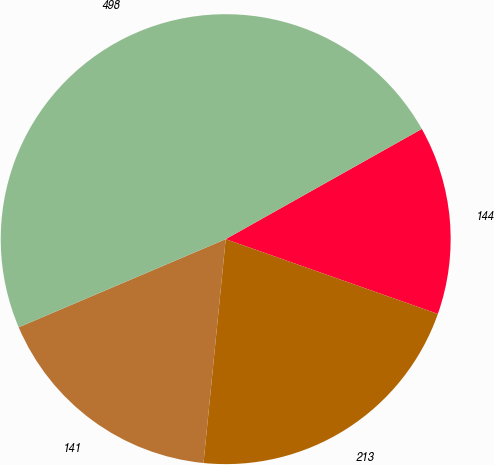Convert chart to OTSL. <chart><loc_0><loc_0><loc_500><loc_500><pie_chart><fcel>144<fcel>213<fcel>141<fcel>498<nl><fcel>13.54%<fcel>21.18%<fcel>17.02%<fcel>48.26%<nl></chart> 